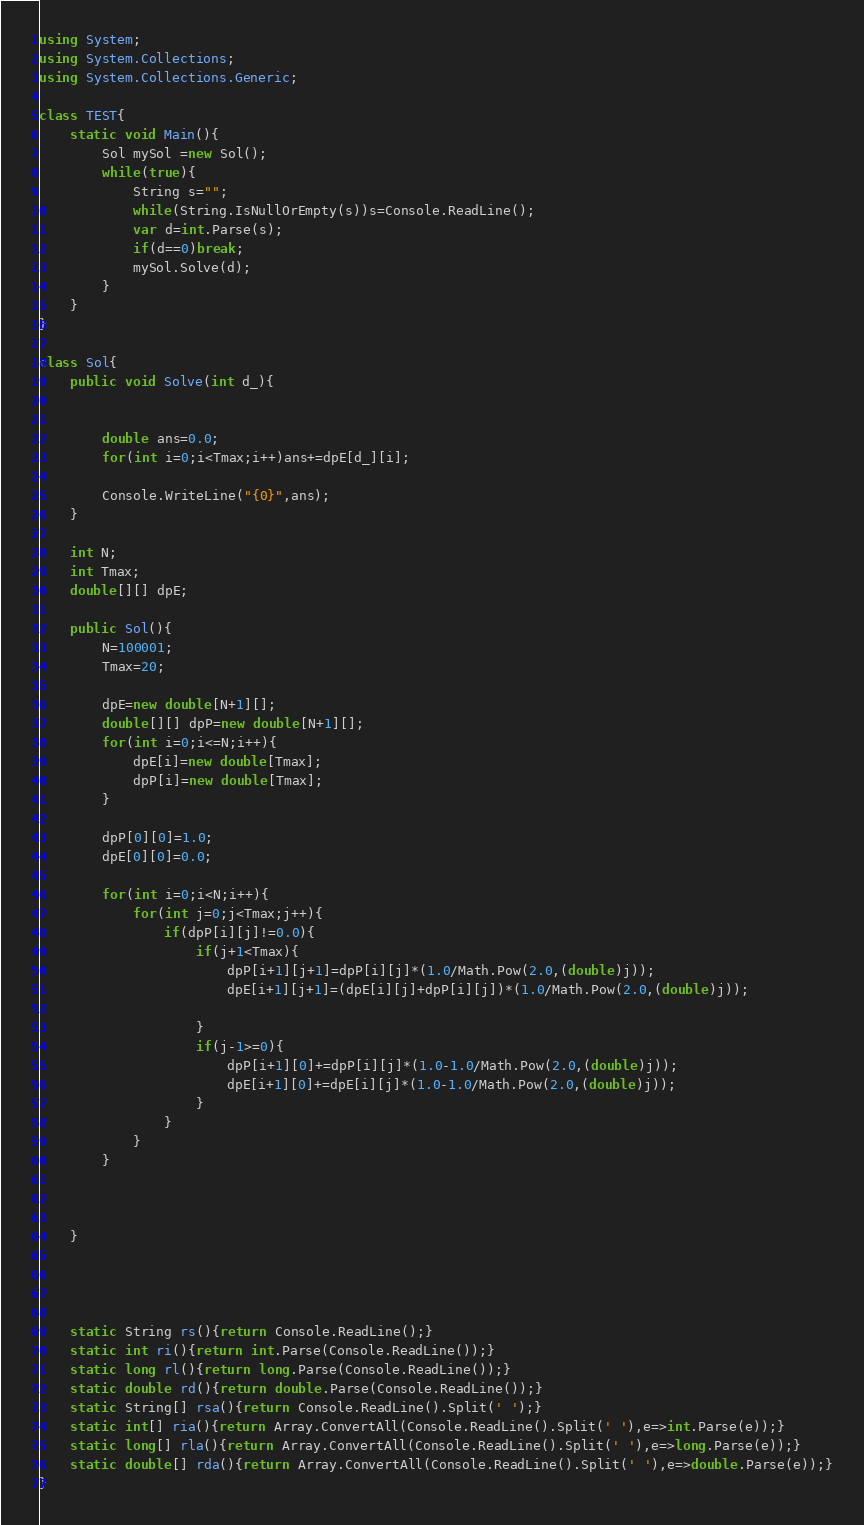Convert code to text. <code><loc_0><loc_0><loc_500><loc_500><_C#_>using System;
using System.Collections;
using System.Collections.Generic;
 
class TEST{
	static void Main(){
		Sol mySol =new Sol();
		while(true){
			String s="";
			while(String.IsNullOrEmpty(s))s=Console.ReadLine();
			var d=int.Parse(s);
			if(d==0)break;
			mySol.Solve(d);
		}
	}
}

class Sol{
	public void Solve(int d_){
		
		
		double ans=0.0;
		for(int i=0;i<Tmax;i++)ans+=dpE[d_][i];
		
		Console.WriteLine("{0}",ans);
	}

	int N;
	int Tmax;
	double[][] dpE;
	
	public Sol(){
		N=100001;
		Tmax=20;
		
		dpE=new double[N+1][];
		double[][] dpP=new double[N+1][];
		for(int i=0;i<=N;i++){
			dpE[i]=new double[Tmax];
			dpP[i]=new double[Tmax];
		}
		
		dpP[0][0]=1.0;
		dpE[0][0]=0.0;
		
		for(int i=0;i<N;i++){
			for(int j=0;j<Tmax;j++){
				if(dpP[i][j]!=0.0){
					if(j+1<Tmax){
						dpP[i+1][j+1]=dpP[i][j]*(1.0/Math.Pow(2.0,(double)j));
						dpE[i+1][j+1]=(dpE[i][j]+dpP[i][j])*(1.0/Math.Pow(2.0,(double)j));
						
					}
					if(j-1>=0){
						dpP[i+1][0]+=dpP[i][j]*(1.0-1.0/Math.Pow(2.0,(double)j));
						dpE[i+1][0]+=dpE[i][j]*(1.0-1.0/Math.Pow(2.0,(double)j));
					}
				}
			}
		}


		
	}




	static String rs(){return Console.ReadLine();}
	static int ri(){return int.Parse(Console.ReadLine());}
	static long rl(){return long.Parse(Console.ReadLine());}
	static double rd(){return double.Parse(Console.ReadLine());}
	static String[] rsa(){return Console.ReadLine().Split(' ');}
	static int[] ria(){return Array.ConvertAll(Console.ReadLine().Split(' '),e=>int.Parse(e));}
	static long[] rla(){return Array.ConvertAll(Console.ReadLine().Split(' '),e=>long.Parse(e));}
	static double[] rda(){return Array.ConvertAll(Console.ReadLine().Split(' '),e=>double.Parse(e));}
}</code> 